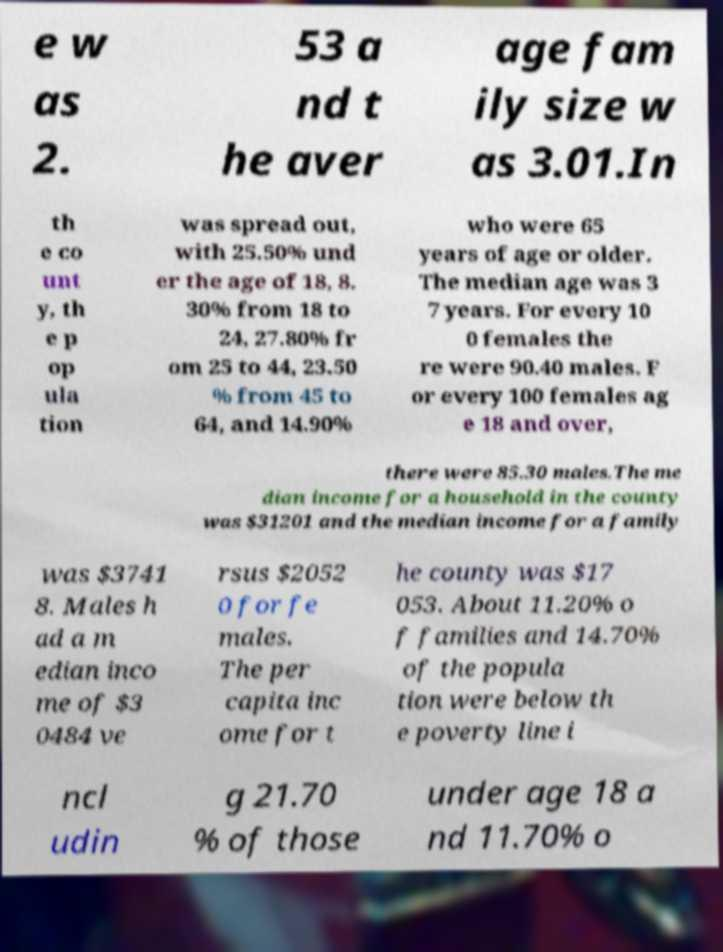I need the written content from this picture converted into text. Can you do that? e w as 2. 53 a nd t he aver age fam ily size w as 3.01.In th e co unt y, th e p op ula tion was spread out, with 25.50% und er the age of 18, 8. 30% from 18 to 24, 27.80% fr om 25 to 44, 23.50 % from 45 to 64, and 14.90% who were 65 years of age or older. The median age was 3 7 years. For every 10 0 females the re were 90.40 males. F or every 100 females ag e 18 and over, there were 85.30 males.The me dian income for a household in the county was $31201 and the median income for a family was $3741 8. Males h ad a m edian inco me of $3 0484 ve rsus $2052 0 for fe males. The per capita inc ome for t he county was $17 053. About 11.20% o f families and 14.70% of the popula tion were below th e poverty line i ncl udin g 21.70 % of those under age 18 a nd 11.70% o 